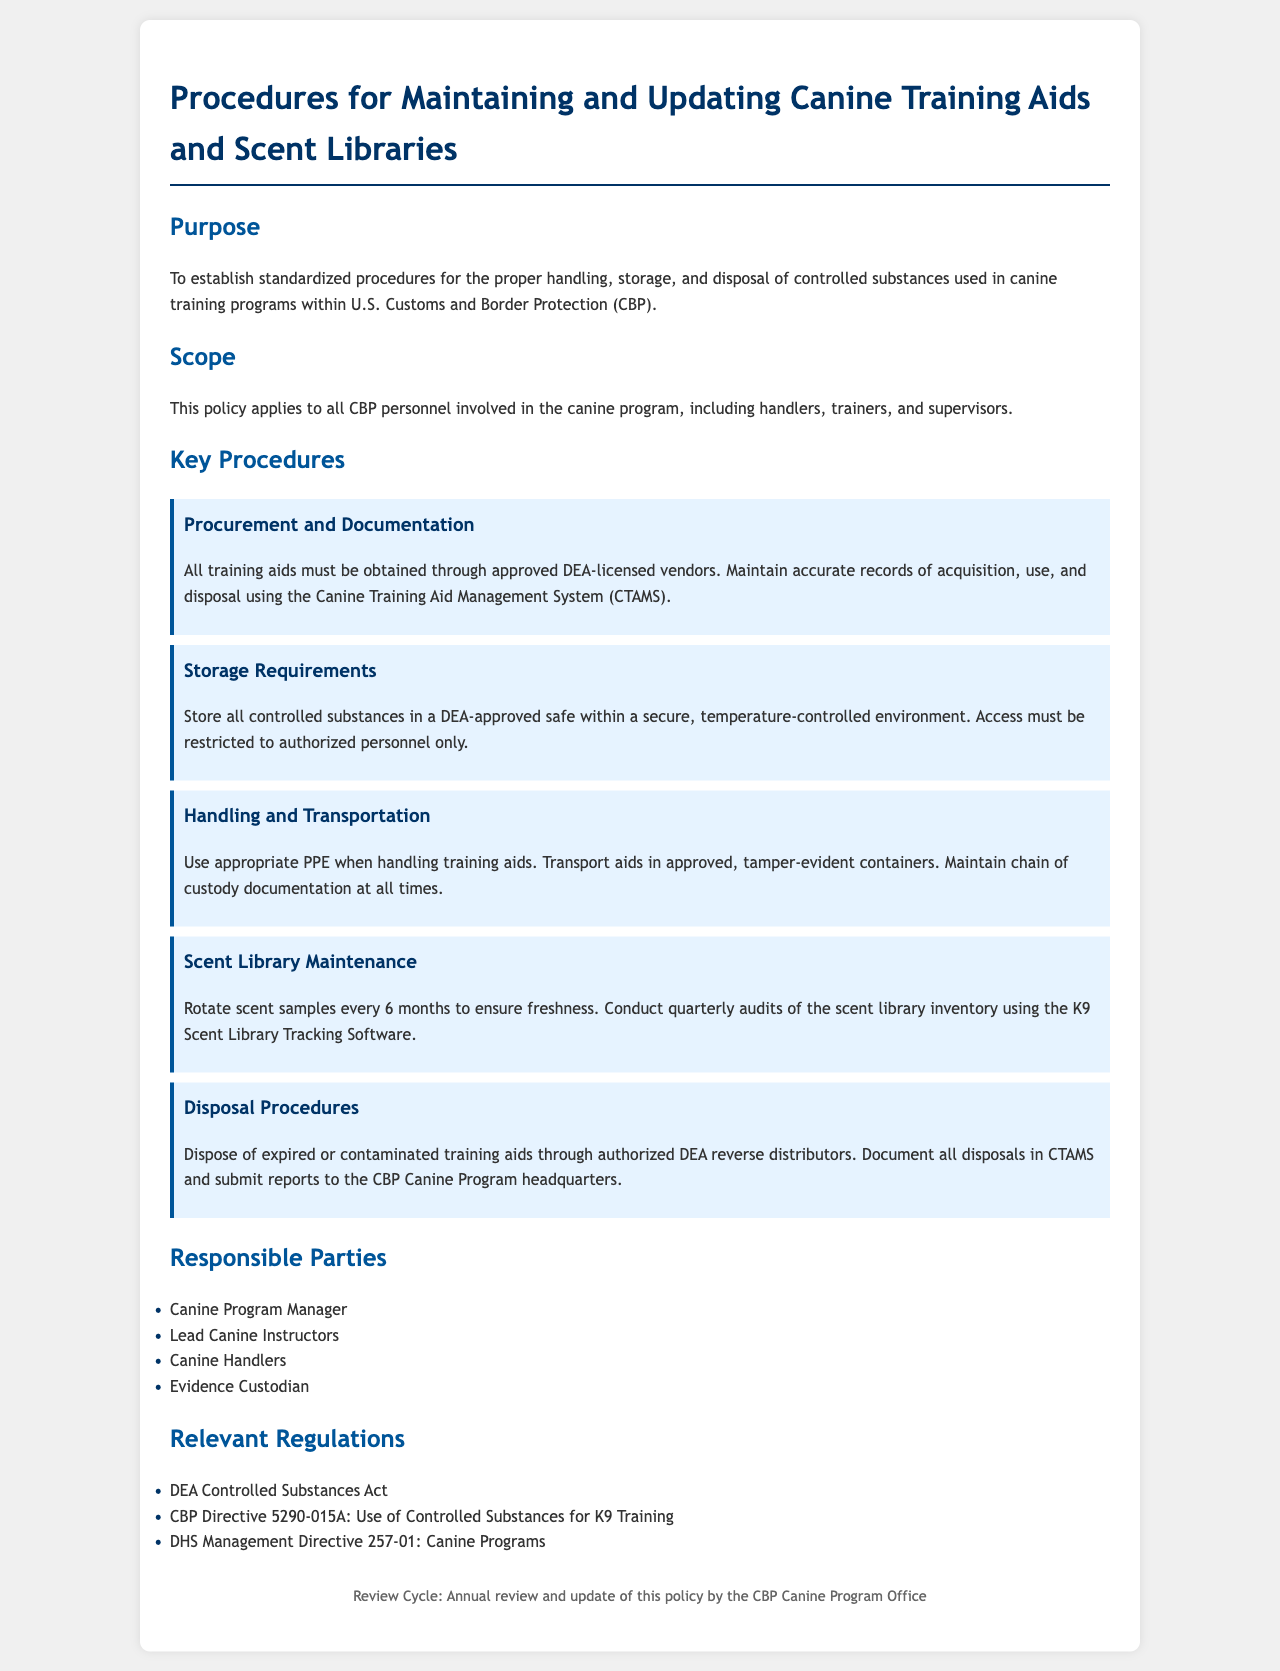What is the purpose of the document? The document establishes standardized procedures for handling, storage, and disposal of controlled substances in canine training programs within CBP.
Answer: To establish standardized procedures for the proper handling, storage, and disposal of controlled substances used in canine training programs within U.S. Customs and Border Protection (CBP) Who is responsible for managing the Canine Program? The document lists responsible parties, including the Canine Program Manager.
Answer: Canine Program Manager What is required for the storage of controlled substances? The document specifies that controlled substances must be stored in a DEA-approved safe within a secure, temperature-controlled environment.
Answer: DEA-approved safe within a secure, temperature-controlled environment How often should scent samples be rotated? The document states scent samples should be rotated every 6 months to maintain freshness.
Answer: Every 6 months List one relevant regulation mentioned in the document. The document includes several regulations; one example is the DEA Controlled Substances Act.
Answer: DEA Controlled Substances Act What software is mentioned for tracking scent library inventory? The document refers to K9 Scent Library Tracking Software for maintaining scent library inventory.
Answer: K9 Scent Library Tracking Software Who must use appropriate PPE when handling training aids? The document indicates that canine handlers should use appropriate PPE when handling training aids.
Answer: Canine handlers What should be done with expired or contaminated training aids? According to the policy, they must be disposed of through authorized DEA reverse distributors.
Answer: Through authorized DEA reverse distributors 